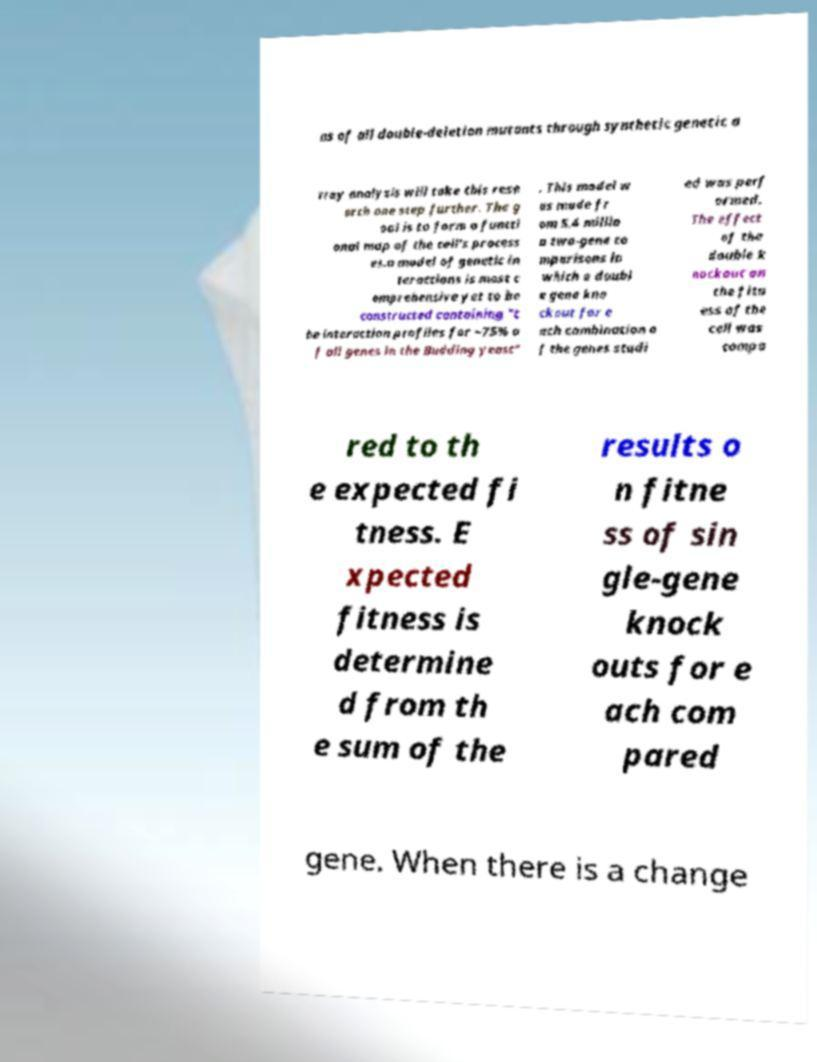I need the written content from this picture converted into text. Can you do that? ns of all double-deletion mutants through synthetic genetic a rray analysis will take this rese arch one step further. The g oal is to form a functi onal map of the cell's process es.a model of genetic in teractions is most c omprehensive yet to be constructed containing "t he interaction profiles for ~75% o f all genes in the Budding yeast" . This model w as made fr om 5.4 millio n two-gene co mparisons in which a doubl e gene kno ckout for e ach combination o f the genes studi ed was perf ormed. The effect of the double k nockout on the fitn ess of the cell was compa red to th e expected fi tness. E xpected fitness is determine d from th e sum of the results o n fitne ss of sin gle-gene knock outs for e ach com pared gene. When there is a change 